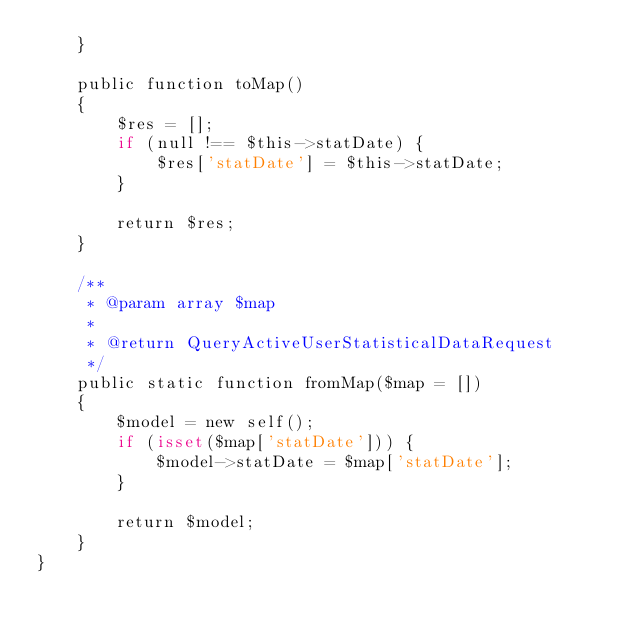<code> <loc_0><loc_0><loc_500><loc_500><_PHP_>    }

    public function toMap()
    {
        $res = [];
        if (null !== $this->statDate) {
            $res['statDate'] = $this->statDate;
        }

        return $res;
    }

    /**
     * @param array $map
     *
     * @return QueryActiveUserStatisticalDataRequest
     */
    public static function fromMap($map = [])
    {
        $model = new self();
        if (isset($map['statDate'])) {
            $model->statDate = $map['statDate'];
        }

        return $model;
    }
}
</code> 